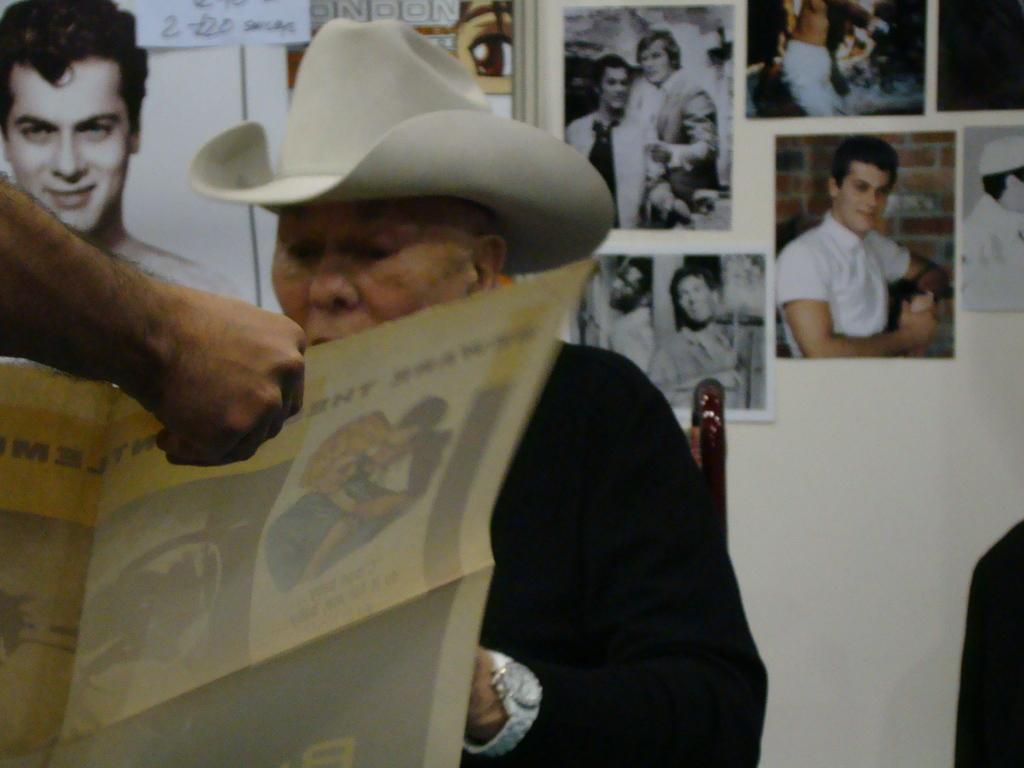What is the person in the image wearing on their head? There is a person wearing a hat in the image. What is the person doing while wearing the hat? The person is sitting on a chair. Can you describe the person on the left side of the image? The person on the left is holding a paper in their hand. What can be seen on the wall in the background of the image? There are photos attached to the wall in the background of the image. Can you see the moon through the window in the image? There is no window or moon present in the image. What is the best way to reach the person sitting on the chair in the image? The image does not provide information about the location or accessibility of the person sitting on the chair, so it is not possible to determine the best way to reach them. 